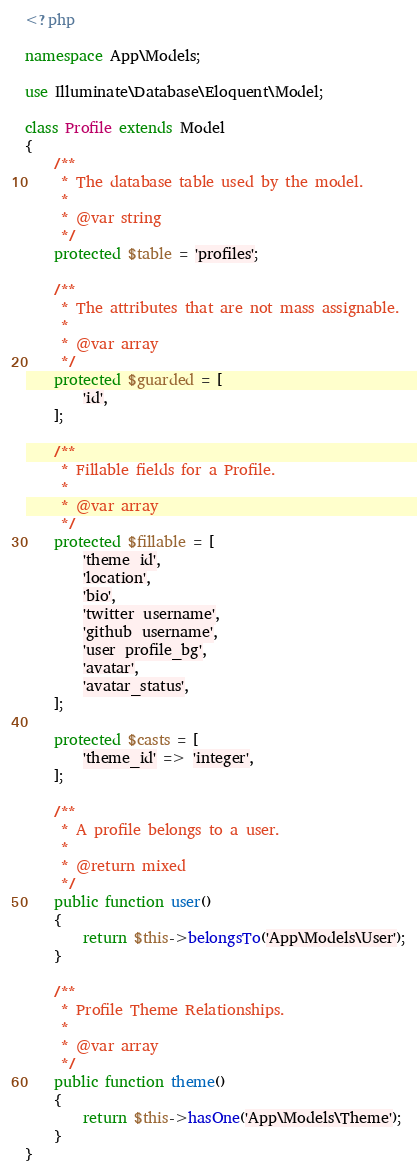<code> <loc_0><loc_0><loc_500><loc_500><_PHP_><?php

namespace App\Models;

use Illuminate\Database\Eloquent\Model;

class Profile extends Model
{
    /**
     * The database table used by the model.
     *
     * @var string
     */
    protected $table = 'profiles';

    /**
     * The attributes that are not mass assignable.
     *
     * @var array
     */
    protected $guarded = [
        'id',
    ];

    /**
     * Fillable fields for a Profile.
     *
     * @var array
     */
    protected $fillable = [
        'theme_id',
        'location',
        'bio',
        'twitter_username',
        'github_username',
        'user_profile_bg',
        'avatar',
        'avatar_status',
    ];

    protected $casts = [
        'theme_id' => 'integer',
    ];

    /**
     * A profile belongs to a user.
     *
     * @return mixed
     */
    public function user()
    {
        return $this->belongsTo('App\Models\User');
    }

    /**
     * Profile Theme Relationships.
     *
     * @var array
     */
    public function theme()
    {
        return $this->hasOne('App\Models\Theme');
    }
}
</code> 